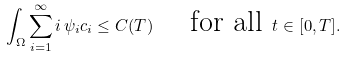Convert formula to latex. <formula><loc_0><loc_0><loc_500><loc_500>\int _ { \Omega } \sum _ { i = 1 } ^ { \infty } i \, \psi _ { i } c _ { i } \leq C ( T ) \quad \text { for all } t \in [ 0 , T ] .</formula> 